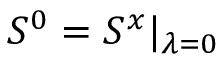<formula> <loc_0><loc_0><loc_500><loc_500>\begin{array} { r } { S ^ { 0 } = S ^ { x } | _ { \lambda = 0 } } \end{array}</formula> 